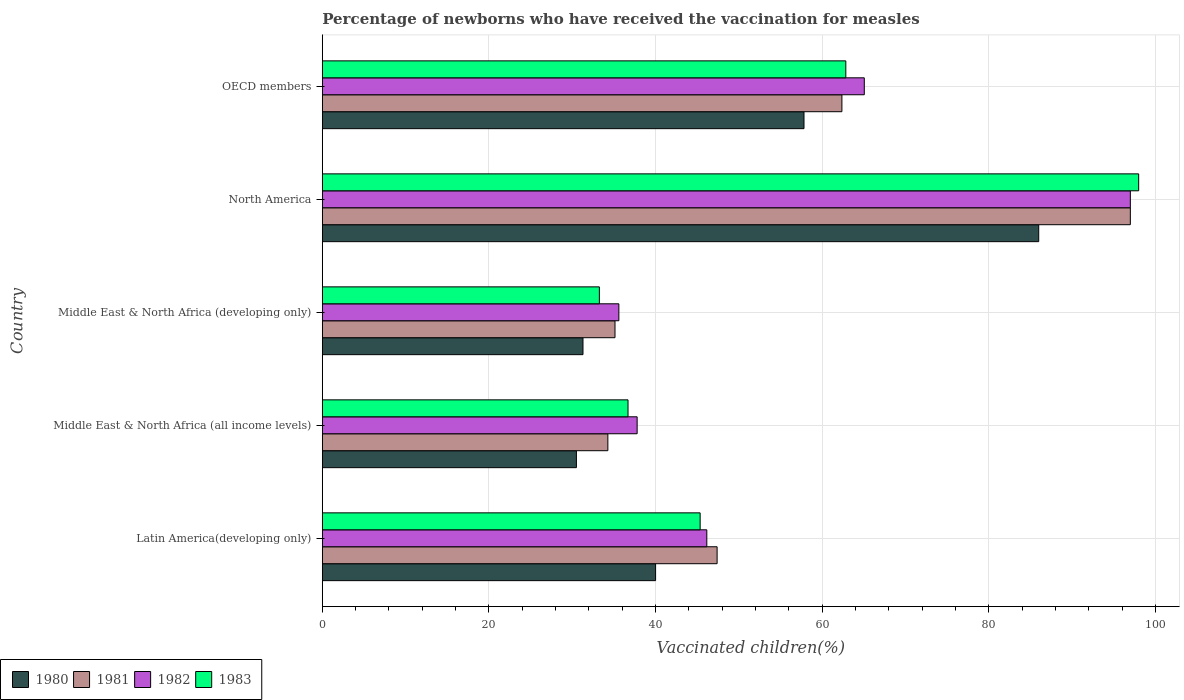How many different coloured bars are there?
Give a very brief answer. 4. How many groups of bars are there?
Offer a terse response. 5. Are the number of bars per tick equal to the number of legend labels?
Give a very brief answer. Yes. Are the number of bars on each tick of the Y-axis equal?
Your answer should be very brief. Yes. How many bars are there on the 5th tick from the bottom?
Give a very brief answer. 4. What is the label of the 4th group of bars from the top?
Offer a very short reply. Middle East & North Africa (all income levels). What is the percentage of vaccinated children in 1981 in Middle East & North Africa (developing only)?
Provide a succinct answer. 35.13. Across all countries, what is the maximum percentage of vaccinated children in 1980?
Keep it short and to the point. 86. Across all countries, what is the minimum percentage of vaccinated children in 1981?
Your answer should be very brief. 34.28. In which country was the percentage of vaccinated children in 1981 maximum?
Offer a very short reply. North America. In which country was the percentage of vaccinated children in 1983 minimum?
Keep it short and to the point. Middle East & North Africa (developing only). What is the total percentage of vaccinated children in 1980 in the graph?
Keep it short and to the point. 245.62. What is the difference between the percentage of vaccinated children in 1980 in North America and that in OECD members?
Give a very brief answer. 28.18. What is the difference between the percentage of vaccinated children in 1982 in North America and the percentage of vaccinated children in 1983 in Middle East & North Africa (developing only)?
Offer a terse response. 63.74. What is the average percentage of vaccinated children in 1983 per country?
Give a very brief answer. 55.23. What is the difference between the percentage of vaccinated children in 1981 and percentage of vaccinated children in 1982 in North America?
Offer a terse response. 0. In how many countries, is the percentage of vaccinated children in 1981 greater than 40 %?
Provide a succinct answer. 3. What is the ratio of the percentage of vaccinated children in 1982 in Latin America(developing only) to that in OECD members?
Provide a succinct answer. 0.71. Is the percentage of vaccinated children in 1983 in Middle East & North Africa (developing only) less than that in North America?
Make the answer very short. Yes. What is the difference between the highest and the second highest percentage of vaccinated children in 1983?
Your answer should be very brief. 35.16. What is the difference between the highest and the lowest percentage of vaccinated children in 1983?
Offer a terse response. 64.74. In how many countries, is the percentage of vaccinated children in 1980 greater than the average percentage of vaccinated children in 1980 taken over all countries?
Offer a very short reply. 2. Is the sum of the percentage of vaccinated children in 1982 in Middle East & North Africa (developing only) and North America greater than the maximum percentage of vaccinated children in 1983 across all countries?
Provide a succinct answer. Yes. Is it the case that in every country, the sum of the percentage of vaccinated children in 1981 and percentage of vaccinated children in 1982 is greater than the sum of percentage of vaccinated children in 1980 and percentage of vaccinated children in 1983?
Your answer should be very brief. No. How many bars are there?
Your answer should be very brief. 20. Are all the bars in the graph horizontal?
Ensure brevity in your answer.  Yes. What is the difference between two consecutive major ticks on the X-axis?
Give a very brief answer. 20. Where does the legend appear in the graph?
Offer a terse response. Bottom left. How are the legend labels stacked?
Ensure brevity in your answer.  Horizontal. What is the title of the graph?
Give a very brief answer. Percentage of newborns who have received the vaccination for measles. What is the label or title of the X-axis?
Your answer should be very brief. Vaccinated children(%). What is the Vaccinated children(%) of 1980 in Latin America(developing only)?
Ensure brevity in your answer.  40.01. What is the Vaccinated children(%) of 1981 in Latin America(developing only)?
Make the answer very short. 47.39. What is the Vaccinated children(%) of 1982 in Latin America(developing only)?
Provide a short and direct response. 46.16. What is the Vaccinated children(%) of 1983 in Latin America(developing only)?
Your response must be concise. 45.35. What is the Vaccinated children(%) of 1980 in Middle East & North Africa (all income levels)?
Make the answer very short. 30.5. What is the Vaccinated children(%) in 1981 in Middle East & North Africa (all income levels)?
Your answer should be compact. 34.28. What is the Vaccinated children(%) of 1982 in Middle East & North Africa (all income levels)?
Offer a very short reply. 37.79. What is the Vaccinated children(%) in 1983 in Middle East & North Africa (all income levels)?
Provide a short and direct response. 36.7. What is the Vaccinated children(%) of 1980 in Middle East & North Africa (developing only)?
Offer a very short reply. 31.29. What is the Vaccinated children(%) in 1981 in Middle East & North Africa (developing only)?
Your answer should be compact. 35.13. What is the Vaccinated children(%) of 1982 in Middle East & North Africa (developing only)?
Offer a terse response. 35.6. What is the Vaccinated children(%) of 1983 in Middle East & North Africa (developing only)?
Provide a short and direct response. 33.26. What is the Vaccinated children(%) in 1980 in North America?
Make the answer very short. 86. What is the Vaccinated children(%) of 1981 in North America?
Provide a short and direct response. 97. What is the Vaccinated children(%) of 1982 in North America?
Keep it short and to the point. 97. What is the Vaccinated children(%) of 1980 in OECD members?
Your answer should be very brief. 57.82. What is the Vaccinated children(%) of 1981 in OECD members?
Offer a very short reply. 62.37. What is the Vaccinated children(%) of 1982 in OECD members?
Provide a short and direct response. 65.06. What is the Vaccinated children(%) in 1983 in OECD members?
Ensure brevity in your answer.  62.84. Across all countries, what is the maximum Vaccinated children(%) in 1980?
Give a very brief answer. 86. Across all countries, what is the maximum Vaccinated children(%) in 1981?
Keep it short and to the point. 97. Across all countries, what is the maximum Vaccinated children(%) of 1982?
Make the answer very short. 97. Across all countries, what is the minimum Vaccinated children(%) of 1980?
Provide a succinct answer. 30.5. Across all countries, what is the minimum Vaccinated children(%) in 1981?
Your answer should be compact. 34.28. Across all countries, what is the minimum Vaccinated children(%) in 1982?
Provide a short and direct response. 35.6. Across all countries, what is the minimum Vaccinated children(%) of 1983?
Make the answer very short. 33.26. What is the total Vaccinated children(%) of 1980 in the graph?
Give a very brief answer. 245.62. What is the total Vaccinated children(%) in 1981 in the graph?
Give a very brief answer. 276.18. What is the total Vaccinated children(%) of 1982 in the graph?
Your response must be concise. 281.61. What is the total Vaccinated children(%) in 1983 in the graph?
Ensure brevity in your answer.  276.15. What is the difference between the Vaccinated children(%) in 1980 in Latin America(developing only) and that in Middle East & North Africa (all income levels)?
Your answer should be compact. 9.51. What is the difference between the Vaccinated children(%) in 1981 in Latin America(developing only) and that in Middle East & North Africa (all income levels)?
Your answer should be compact. 13.11. What is the difference between the Vaccinated children(%) in 1982 in Latin America(developing only) and that in Middle East & North Africa (all income levels)?
Your answer should be compact. 8.36. What is the difference between the Vaccinated children(%) in 1983 in Latin America(developing only) and that in Middle East & North Africa (all income levels)?
Your answer should be compact. 8.66. What is the difference between the Vaccinated children(%) in 1980 in Latin America(developing only) and that in Middle East & North Africa (developing only)?
Provide a succinct answer. 8.72. What is the difference between the Vaccinated children(%) of 1981 in Latin America(developing only) and that in Middle East & North Africa (developing only)?
Keep it short and to the point. 12.26. What is the difference between the Vaccinated children(%) in 1982 in Latin America(developing only) and that in Middle East & North Africa (developing only)?
Make the answer very short. 10.56. What is the difference between the Vaccinated children(%) of 1983 in Latin America(developing only) and that in Middle East & North Africa (developing only)?
Offer a terse response. 12.1. What is the difference between the Vaccinated children(%) in 1980 in Latin America(developing only) and that in North America?
Ensure brevity in your answer.  -45.99. What is the difference between the Vaccinated children(%) in 1981 in Latin America(developing only) and that in North America?
Ensure brevity in your answer.  -49.61. What is the difference between the Vaccinated children(%) in 1982 in Latin America(developing only) and that in North America?
Provide a short and direct response. -50.84. What is the difference between the Vaccinated children(%) in 1983 in Latin America(developing only) and that in North America?
Make the answer very short. -52.65. What is the difference between the Vaccinated children(%) in 1980 in Latin America(developing only) and that in OECD members?
Offer a terse response. -17.82. What is the difference between the Vaccinated children(%) of 1981 in Latin America(developing only) and that in OECD members?
Your answer should be very brief. -14.98. What is the difference between the Vaccinated children(%) of 1982 in Latin America(developing only) and that in OECD members?
Make the answer very short. -18.91. What is the difference between the Vaccinated children(%) in 1983 in Latin America(developing only) and that in OECD members?
Make the answer very short. -17.49. What is the difference between the Vaccinated children(%) in 1980 in Middle East & North Africa (all income levels) and that in Middle East & North Africa (developing only)?
Make the answer very short. -0.79. What is the difference between the Vaccinated children(%) in 1981 in Middle East & North Africa (all income levels) and that in Middle East & North Africa (developing only)?
Offer a very short reply. -0.86. What is the difference between the Vaccinated children(%) in 1982 in Middle East & North Africa (all income levels) and that in Middle East & North Africa (developing only)?
Give a very brief answer. 2.19. What is the difference between the Vaccinated children(%) in 1983 in Middle East & North Africa (all income levels) and that in Middle East & North Africa (developing only)?
Your answer should be very brief. 3.44. What is the difference between the Vaccinated children(%) in 1980 in Middle East & North Africa (all income levels) and that in North America?
Your answer should be compact. -55.5. What is the difference between the Vaccinated children(%) of 1981 in Middle East & North Africa (all income levels) and that in North America?
Your answer should be very brief. -62.72. What is the difference between the Vaccinated children(%) of 1982 in Middle East & North Africa (all income levels) and that in North America?
Give a very brief answer. -59.21. What is the difference between the Vaccinated children(%) in 1983 in Middle East & North Africa (all income levels) and that in North America?
Provide a succinct answer. -61.3. What is the difference between the Vaccinated children(%) of 1980 in Middle East & North Africa (all income levels) and that in OECD members?
Offer a very short reply. -27.32. What is the difference between the Vaccinated children(%) of 1981 in Middle East & North Africa (all income levels) and that in OECD members?
Your answer should be very brief. -28.1. What is the difference between the Vaccinated children(%) in 1982 in Middle East & North Africa (all income levels) and that in OECD members?
Your response must be concise. -27.27. What is the difference between the Vaccinated children(%) of 1983 in Middle East & North Africa (all income levels) and that in OECD members?
Offer a terse response. -26.15. What is the difference between the Vaccinated children(%) of 1980 in Middle East & North Africa (developing only) and that in North America?
Your answer should be compact. -54.71. What is the difference between the Vaccinated children(%) in 1981 in Middle East & North Africa (developing only) and that in North America?
Your answer should be compact. -61.87. What is the difference between the Vaccinated children(%) in 1982 in Middle East & North Africa (developing only) and that in North America?
Offer a terse response. -61.4. What is the difference between the Vaccinated children(%) in 1983 in Middle East & North Africa (developing only) and that in North America?
Make the answer very short. -64.74. What is the difference between the Vaccinated children(%) of 1980 in Middle East & North Africa (developing only) and that in OECD members?
Offer a very short reply. -26.53. What is the difference between the Vaccinated children(%) in 1981 in Middle East & North Africa (developing only) and that in OECD members?
Offer a very short reply. -27.24. What is the difference between the Vaccinated children(%) of 1982 in Middle East & North Africa (developing only) and that in OECD members?
Make the answer very short. -29.46. What is the difference between the Vaccinated children(%) in 1983 in Middle East & North Africa (developing only) and that in OECD members?
Your answer should be very brief. -29.59. What is the difference between the Vaccinated children(%) of 1980 in North America and that in OECD members?
Provide a succinct answer. 28.18. What is the difference between the Vaccinated children(%) in 1981 in North America and that in OECD members?
Ensure brevity in your answer.  34.63. What is the difference between the Vaccinated children(%) in 1982 in North America and that in OECD members?
Make the answer very short. 31.94. What is the difference between the Vaccinated children(%) in 1983 in North America and that in OECD members?
Offer a very short reply. 35.16. What is the difference between the Vaccinated children(%) of 1980 in Latin America(developing only) and the Vaccinated children(%) of 1981 in Middle East & North Africa (all income levels)?
Offer a terse response. 5.73. What is the difference between the Vaccinated children(%) of 1980 in Latin America(developing only) and the Vaccinated children(%) of 1982 in Middle East & North Africa (all income levels)?
Offer a terse response. 2.22. What is the difference between the Vaccinated children(%) of 1980 in Latin America(developing only) and the Vaccinated children(%) of 1983 in Middle East & North Africa (all income levels)?
Give a very brief answer. 3.31. What is the difference between the Vaccinated children(%) in 1981 in Latin America(developing only) and the Vaccinated children(%) in 1982 in Middle East & North Africa (all income levels)?
Provide a succinct answer. 9.6. What is the difference between the Vaccinated children(%) in 1981 in Latin America(developing only) and the Vaccinated children(%) in 1983 in Middle East & North Africa (all income levels)?
Your answer should be compact. 10.7. What is the difference between the Vaccinated children(%) in 1982 in Latin America(developing only) and the Vaccinated children(%) in 1983 in Middle East & North Africa (all income levels)?
Your answer should be compact. 9.46. What is the difference between the Vaccinated children(%) in 1980 in Latin America(developing only) and the Vaccinated children(%) in 1981 in Middle East & North Africa (developing only)?
Provide a short and direct response. 4.87. What is the difference between the Vaccinated children(%) of 1980 in Latin America(developing only) and the Vaccinated children(%) of 1982 in Middle East & North Africa (developing only)?
Your answer should be very brief. 4.41. What is the difference between the Vaccinated children(%) of 1980 in Latin America(developing only) and the Vaccinated children(%) of 1983 in Middle East & North Africa (developing only)?
Make the answer very short. 6.75. What is the difference between the Vaccinated children(%) in 1981 in Latin America(developing only) and the Vaccinated children(%) in 1982 in Middle East & North Africa (developing only)?
Make the answer very short. 11.8. What is the difference between the Vaccinated children(%) in 1981 in Latin America(developing only) and the Vaccinated children(%) in 1983 in Middle East & North Africa (developing only)?
Your answer should be very brief. 14.14. What is the difference between the Vaccinated children(%) in 1982 in Latin America(developing only) and the Vaccinated children(%) in 1983 in Middle East & North Africa (developing only)?
Ensure brevity in your answer.  12.9. What is the difference between the Vaccinated children(%) in 1980 in Latin America(developing only) and the Vaccinated children(%) in 1981 in North America?
Your answer should be very brief. -56.99. What is the difference between the Vaccinated children(%) in 1980 in Latin America(developing only) and the Vaccinated children(%) in 1982 in North America?
Your answer should be very brief. -56.99. What is the difference between the Vaccinated children(%) in 1980 in Latin America(developing only) and the Vaccinated children(%) in 1983 in North America?
Keep it short and to the point. -57.99. What is the difference between the Vaccinated children(%) in 1981 in Latin America(developing only) and the Vaccinated children(%) in 1982 in North America?
Ensure brevity in your answer.  -49.61. What is the difference between the Vaccinated children(%) in 1981 in Latin America(developing only) and the Vaccinated children(%) in 1983 in North America?
Ensure brevity in your answer.  -50.61. What is the difference between the Vaccinated children(%) in 1982 in Latin America(developing only) and the Vaccinated children(%) in 1983 in North America?
Keep it short and to the point. -51.84. What is the difference between the Vaccinated children(%) of 1980 in Latin America(developing only) and the Vaccinated children(%) of 1981 in OECD members?
Your response must be concise. -22.37. What is the difference between the Vaccinated children(%) in 1980 in Latin America(developing only) and the Vaccinated children(%) in 1982 in OECD members?
Provide a short and direct response. -25.05. What is the difference between the Vaccinated children(%) of 1980 in Latin America(developing only) and the Vaccinated children(%) of 1983 in OECD members?
Make the answer very short. -22.84. What is the difference between the Vaccinated children(%) of 1981 in Latin America(developing only) and the Vaccinated children(%) of 1982 in OECD members?
Your answer should be compact. -17.67. What is the difference between the Vaccinated children(%) of 1981 in Latin America(developing only) and the Vaccinated children(%) of 1983 in OECD members?
Give a very brief answer. -15.45. What is the difference between the Vaccinated children(%) in 1982 in Latin America(developing only) and the Vaccinated children(%) in 1983 in OECD members?
Give a very brief answer. -16.69. What is the difference between the Vaccinated children(%) in 1980 in Middle East & North Africa (all income levels) and the Vaccinated children(%) in 1981 in Middle East & North Africa (developing only)?
Provide a short and direct response. -4.63. What is the difference between the Vaccinated children(%) in 1980 in Middle East & North Africa (all income levels) and the Vaccinated children(%) in 1982 in Middle East & North Africa (developing only)?
Provide a succinct answer. -5.1. What is the difference between the Vaccinated children(%) in 1980 in Middle East & North Africa (all income levels) and the Vaccinated children(%) in 1983 in Middle East & North Africa (developing only)?
Your answer should be very brief. -2.75. What is the difference between the Vaccinated children(%) in 1981 in Middle East & North Africa (all income levels) and the Vaccinated children(%) in 1982 in Middle East & North Africa (developing only)?
Your answer should be very brief. -1.32. What is the difference between the Vaccinated children(%) of 1981 in Middle East & North Africa (all income levels) and the Vaccinated children(%) of 1983 in Middle East & North Africa (developing only)?
Offer a very short reply. 1.02. What is the difference between the Vaccinated children(%) in 1982 in Middle East & North Africa (all income levels) and the Vaccinated children(%) in 1983 in Middle East & North Africa (developing only)?
Provide a succinct answer. 4.54. What is the difference between the Vaccinated children(%) of 1980 in Middle East & North Africa (all income levels) and the Vaccinated children(%) of 1981 in North America?
Ensure brevity in your answer.  -66.5. What is the difference between the Vaccinated children(%) in 1980 in Middle East & North Africa (all income levels) and the Vaccinated children(%) in 1982 in North America?
Your response must be concise. -66.5. What is the difference between the Vaccinated children(%) of 1980 in Middle East & North Africa (all income levels) and the Vaccinated children(%) of 1983 in North America?
Provide a short and direct response. -67.5. What is the difference between the Vaccinated children(%) in 1981 in Middle East & North Africa (all income levels) and the Vaccinated children(%) in 1982 in North America?
Your answer should be compact. -62.72. What is the difference between the Vaccinated children(%) in 1981 in Middle East & North Africa (all income levels) and the Vaccinated children(%) in 1983 in North America?
Your response must be concise. -63.72. What is the difference between the Vaccinated children(%) in 1982 in Middle East & North Africa (all income levels) and the Vaccinated children(%) in 1983 in North America?
Provide a short and direct response. -60.21. What is the difference between the Vaccinated children(%) of 1980 in Middle East & North Africa (all income levels) and the Vaccinated children(%) of 1981 in OECD members?
Offer a very short reply. -31.87. What is the difference between the Vaccinated children(%) of 1980 in Middle East & North Africa (all income levels) and the Vaccinated children(%) of 1982 in OECD members?
Provide a short and direct response. -34.56. What is the difference between the Vaccinated children(%) in 1980 in Middle East & North Africa (all income levels) and the Vaccinated children(%) in 1983 in OECD members?
Your answer should be very brief. -32.34. What is the difference between the Vaccinated children(%) of 1981 in Middle East & North Africa (all income levels) and the Vaccinated children(%) of 1982 in OECD members?
Your answer should be compact. -30.78. What is the difference between the Vaccinated children(%) of 1981 in Middle East & North Africa (all income levels) and the Vaccinated children(%) of 1983 in OECD members?
Provide a succinct answer. -28.57. What is the difference between the Vaccinated children(%) of 1982 in Middle East & North Africa (all income levels) and the Vaccinated children(%) of 1983 in OECD members?
Provide a short and direct response. -25.05. What is the difference between the Vaccinated children(%) in 1980 in Middle East & North Africa (developing only) and the Vaccinated children(%) in 1981 in North America?
Keep it short and to the point. -65.71. What is the difference between the Vaccinated children(%) in 1980 in Middle East & North Africa (developing only) and the Vaccinated children(%) in 1982 in North America?
Give a very brief answer. -65.71. What is the difference between the Vaccinated children(%) in 1980 in Middle East & North Africa (developing only) and the Vaccinated children(%) in 1983 in North America?
Your response must be concise. -66.71. What is the difference between the Vaccinated children(%) in 1981 in Middle East & North Africa (developing only) and the Vaccinated children(%) in 1982 in North America?
Ensure brevity in your answer.  -61.87. What is the difference between the Vaccinated children(%) of 1981 in Middle East & North Africa (developing only) and the Vaccinated children(%) of 1983 in North America?
Your answer should be compact. -62.87. What is the difference between the Vaccinated children(%) of 1982 in Middle East & North Africa (developing only) and the Vaccinated children(%) of 1983 in North America?
Your answer should be very brief. -62.4. What is the difference between the Vaccinated children(%) in 1980 in Middle East & North Africa (developing only) and the Vaccinated children(%) in 1981 in OECD members?
Offer a terse response. -31.08. What is the difference between the Vaccinated children(%) of 1980 in Middle East & North Africa (developing only) and the Vaccinated children(%) of 1982 in OECD members?
Your answer should be compact. -33.77. What is the difference between the Vaccinated children(%) of 1980 in Middle East & North Africa (developing only) and the Vaccinated children(%) of 1983 in OECD members?
Provide a short and direct response. -31.55. What is the difference between the Vaccinated children(%) in 1981 in Middle East & North Africa (developing only) and the Vaccinated children(%) in 1982 in OECD members?
Offer a terse response. -29.93. What is the difference between the Vaccinated children(%) in 1981 in Middle East & North Africa (developing only) and the Vaccinated children(%) in 1983 in OECD members?
Your response must be concise. -27.71. What is the difference between the Vaccinated children(%) in 1982 in Middle East & North Africa (developing only) and the Vaccinated children(%) in 1983 in OECD members?
Offer a terse response. -27.25. What is the difference between the Vaccinated children(%) of 1980 in North America and the Vaccinated children(%) of 1981 in OECD members?
Offer a very short reply. 23.63. What is the difference between the Vaccinated children(%) of 1980 in North America and the Vaccinated children(%) of 1982 in OECD members?
Offer a very short reply. 20.94. What is the difference between the Vaccinated children(%) of 1980 in North America and the Vaccinated children(%) of 1983 in OECD members?
Make the answer very short. 23.16. What is the difference between the Vaccinated children(%) of 1981 in North America and the Vaccinated children(%) of 1982 in OECD members?
Provide a short and direct response. 31.94. What is the difference between the Vaccinated children(%) in 1981 in North America and the Vaccinated children(%) in 1983 in OECD members?
Keep it short and to the point. 34.16. What is the difference between the Vaccinated children(%) of 1982 in North America and the Vaccinated children(%) of 1983 in OECD members?
Your response must be concise. 34.16. What is the average Vaccinated children(%) in 1980 per country?
Offer a terse response. 49.12. What is the average Vaccinated children(%) of 1981 per country?
Offer a terse response. 55.24. What is the average Vaccinated children(%) of 1982 per country?
Make the answer very short. 56.32. What is the average Vaccinated children(%) of 1983 per country?
Make the answer very short. 55.23. What is the difference between the Vaccinated children(%) of 1980 and Vaccinated children(%) of 1981 in Latin America(developing only)?
Keep it short and to the point. -7.39. What is the difference between the Vaccinated children(%) of 1980 and Vaccinated children(%) of 1982 in Latin America(developing only)?
Make the answer very short. -6.15. What is the difference between the Vaccinated children(%) of 1980 and Vaccinated children(%) of 1983 in Latin America(developing only)?
Make the answer very short. -5.35. What is the difference between the Vaccinated children(%) of 1981 and Vaccinated children(%) of 1982 in Latin America(developing only)?
Make the answer very short. 1.24. What is the difference between the Vaccinated children(%) of 1981 and Vaccinated children(%) of 1983 in Latin America(developing only)?
Ensure brevity in your answer.  2.04. What is the difference between the Vaccinated children(%) in 1982 and Vaccinated children(%) in 1983 in Latin America(developing only)?
Make the answer very short. 0.8. What is the difference between the Vaccinated children(%) in 1980 and Vaccinated children(%) in 1981 in Middle East & North Africa (all income levels)?
Ensure brevity in your answer.  -3.78. What is the difference between the Vaccinated children(%) in 1980 and Vaccinated children(%) in 1982 in Middle East & North Africa (all income levels)?
Your answer should be very brief. -7.29. What is the difference between the Vaccinated children(%) in 1980 and Vaccinated children(%) in 1983 in Middle East & North Africa (all income levels)?
Give a very brief answer. -6.19. What is the difference between the Vaccinated children(%) of 1981 and Vaccinated children(%) of 1982 in Middle East & North Africa (all income levels)?
Make the answer very short. -3.51. What is the difference between the Vaccinated children(%) of 1981 and Vaccinated children(%) of 1983 in Middle East & North Africa (all income levels)?
Your response must be concise. -2.42. What is the difference between the Vaccinated children(%) of 1982 and Vaccinated children(%) of 1983 in Middle East & North Africa (all income levels)?
Your answer should be compact. 1.1. What is the difference between the Vaccinated children(%) in 1980 and Vaccinated children(%) in 1981 in Middle East & North Africa (developing only)?
Give a very brief answer. -3.84. What is the difference between the Vaccinated children(%) of 1980 and Vaccinated children(%) of 1982 in Middle East & North Africa (developing only)?
Provide a succinct answer. -4.31. What is the difference between the Vaccinated children(%) in 1980 and Vaccinated children(%) in 1983 in Middle East & North Africa (developing only)?
Make the answer very short. -1.97. What is the difference between the Vaccinated children(%) in 1981 and Vaccinated children(%) in 1982 in Middle East & North Africa (developing only)?
Provide a succinct answer. -0.46. What is the difference between the Vaccinated children(%) of 1981 and Vaccinated children(%) of 1983 in Middle East & North Africa (developing only)?
Your answer should be very brief. 1.88. What is the difference between the Vaccinated children(%) in 1982 and Vaccinated children(%) in 1983 in Middle East & North Africa (developing only)?
Give a very brief answer. 2.34. What is the difference between the Vaccinated children(%) of 1980 and Vaccinated children(%) of 1981 in North America?
Ensure brevity in your answer.  -11. What is the difference between the Vaccinated children(%) in 1980 and Vaccinated children(%) in 1982 in North America?
Your answer should be very brief. -11. What is the difference between the Vaccinated children(%) in 1981 and Vaccinated children(%) in 1982 in North America?
Offer a terse response. 0. What is the difference between the Vaccinated children(%) of 1981 and Vaccinated children(%) of 1983 in North America?
Provide a succinct answer. -1. What is the difference between the Vaccinated children(%) of 1982 and Vaccinated children(%) of 1983 in North America?
Provide a short and direct response. -1. What is the difference between the Vaccinated children(%) in 1980 and Vaccinated children(%) in 1981 in OECD members?
Your answer should be compact. -4.55. What is the difference between the Vaccinated children(%) of 1980 and Vaccinated children(%) of 1982 in OECD members?
Make the answer very short. -7.24. What is the difference between the Vaccinated children(%) in 1980 and Vaccinated children(%) in 1983 in OECD members?
Give a very brief answer. -5.02. What is the difference between the Vaccinated children(%) of 1981 and Vaccinated children(%) of 1982 in OECD members?
Keep it short and to the point. -2.69. What is the difference between the Vaccinated children(%) in 1981 and Vaccinated children(%) in 1983 in OECD members?
Give a very brief answer. -0.47. What is the difference between the Vaccinated children(%) in 1982 and Vaccinated children(%) in 1983 in OECD members?
Make the answer very short. 2.22. What is the ratio of the Vaccinated children(%) in 1980 in Latin America(developing only) to that in Middle East & North Africa (all income levels)?
Your answer should be compact. 1.31. What is the ratio of the Vaccinated children(%) of 1981 in Latin America(developing only) to that in Middle East & North Africa (all income levels)?
Offer a terse response. 1.38. What is the ratio of the Vaccinated children(%) of 1982 in Latin America(developing only) to that in Middle East & North Africa (all income levels)?
Your answer should be compact. 1.22. What is the ratio of the Vaccinated children(%) of 1983 in Latin America(developing only) to that in Middle East & North Africa (all income levels)?
Ensure brevity in your answer.  1.24. What is the ratio of the Vaccinated children(%) in 1980 in Latin America(developing only) to that in Middle East & North Africa (developing only)?
Provide a short and direct response. 1.28. What is the ratio of the Vaccinated children(%) in 1981 in Latin America(developing only) to that in Middle East & North Africa (developing only)?
Your answer should be compact. 1.35. What is the ratio of the Vaccinated children(%) in 1982 in Latin America(developing only) to that in Middle East & North Africa (developing only)?
Provide a short and direct response. 1.3. What is the ratio of the Vaccinated children(%) in 1983 in Latin America(developing only) to that in Middle East & North Africa (developing only)?
Provide a short and direct response. 1.36. What is the ratio of the Vaccinated children(%) of 1980 in Latin America(developing only) to that in North America?
Offer a terse response. 0.47. What is the ratio of the Vaccinated children(%) of 1981 in Latin America(developing only) to that in North America?
Your answer should be compact. 0.49. What is the ratio of the Vaccinated children(%) in 1982 in Latin America(developing only) to that in North America?
Give a very brief answer. 0.48. What is the ratio of the Vaccinated children(%) of 1983 in Latin America(developing only) to that in North America?
Provide a short and direct response. 0.46. What is the ratio of the Vaccinated children(%) of 1980 in Latin America(developing only) to that in OECD members?
Ensure brevity in your answer.  0.69. What is the ratio of the Vaccinated children(%) of 1981 in Latin America(developing only) to that in OECD members?
Make the answer very short. 0.76. What is the ratio of the Vaccinated children(%) of 1982 in Latin America(developing only) to that in OECD members?
Your response must be concise. 0.71. What is the ratio of the Vaccinated children(%) in 1983 in Latin America(developing only) to that in OECD members?
Your response must be concise. 0.72. What is the ratio of the Vaccinated children(%) of 1980 in Middle East & North Africa (all income levels) to that in Middle East & North Africa (developing only)?
Make the answer very short. 0.97. What is the ratio of the Vaccinated children(%) of 1981 in Middle East & North Africa (all income levels) to that in Middle East & North Africa (developing only)?
Provide a short and direct response. 0.98. What is the ratio of the Vaccinated children(%) in 1982 in Middle East & North Africa (all income levels) to that in Middle East & North Africa (developing only)?
Make the answer very short. 1.06. What is the ratio of the Vaccinated children(%) in 1983 in Middle East & North Africa (all income levels) to that in Middle East & North Africa (developing only)?
Ensure brevity in your answer.  1.1. What is the ratio of the Vaccinated children(%) in 1980 in Middle East & North Africa (all income levels) to that in North America?
Provide a succinct answer. 0.35. What is the ratio of the Vaccinated children(%) of 1981 in Middle East & North Africa (all income levels) to that in North America?
Your answer should be very brief. 0.35. What is the ratio of the Vaccinated children(%) in 1982 in Middle East & North Africa (all income levels) to that in North America?
Make the answer very short. 0.39. What is the ratio of the Vaccinated children(%) in 1983 in Middle East & North Africa (all income levels) to that in North America?
Give a very brief answer. 0.37. What is the ratio of the Vaccinated children(%) in 1980 in Middle East & North Africa (all income levels) to that in OECD members?
Give a very brief answer. 0.53. What is the ratio of the Vaccinated children(%) in 1981 in Middle East & North Africa (all income levels) to that in OECD members?
Offer a very short reply. 0.55. What is the ratio of the Vaccinated children(%) of 1982 in Middle East & North Africa (all income levels) to that in OECD members?
Your answer should be compact. 0.58. What is the ratio of the Vaccinated children(%) of 1983 in Middle East & North Africa (all income levels) to that in OECD members?
Ensure brevity in your answer.  0.58. What is the ratio of the Vaccinated children(%) of 1980 in Middle East & North Africa (developing only) to that in North America?
Offer a very short reply. 0.36. What is the ratio of the Vaccinated children(%) in 1981 in Middle East & North Africa (developing only) to that in North America?
Keep it short and to the point. 0.36. What is the ratio of the Vaccinated children(%) in 1982 in Middle East & North Africa (developing only) to that in North America?
Make the answer very short. 0.37. What is the ratio of the Vaccinated children(%) of 1983 in Middle East & North Africa (developing only) to that in North America?
Give a very brief answer. 0.34. What is the ratio of the Vaccinated children(%) of 1980 in Middle East & North Africa (developing only) to that in OECD members?
Make the answer very short. 0.54. What is the ratio of the Vaccinated children(%) of 1981 in Middle East & North Africa (developing only) to that in OECD members?
Offer a terse response. 0.56. What is the ratio of the Vaccinated children(%) in 1982 in Middle East & North Africa (developing only) to that in OECD members?
Give a very brief answer. 0.55. What is the ratio of the Vaccinated children(%) of 1983 in Middle East & North Africa (developing only) to that in OECD members?
Offer a very short reply. 0.53. What is the ratio of the Vaccinated children(%) in 1980 in North America to that in OECD members?
Offer a very short reply. 1.49. What is the ratio of the Vaccinated children(%) in 1981 in North America to that in OECD members?
Give a very brief answer. 1.56. What is the ratio of the Vaccinated children(%) in 1982 in North America to that in OECD members?
Your answer should be very brief. 1.49. What is the ratio of the Vaccinated children(%) of 1983 in North America to that in OECD members?
Ensure brevity in your answer.  1.56. What is the difference between the highest and the second highest Vaccinated children(%) in 1980?
Your response must be concise. 28.18. What is the difference between the highest and the second highest Vaccinated children(%) of 1981?
Offer a very short reply. 34.63. What is the difference between the highest and the second highest Vaccinated children(%) of 1982?
Your response must be concise. 31.94. What is the difference between the highest and the second highest Vaccinated children(%) of 1983?
Your answer should be very brief. 35.16. What is the difference between the highest and the lowest Vaccinated children(%) of 1980?
Offer a terse response. 55.5. What is the difference between the highest and the lowest Vaccinated children(%) of 1981?
Your response must be concise. 62.72. What is the difference between the highest and the lowest Vaccinated children(%) in 1982?
Your answer should be compact. 61.4. What is the difference between the highest and the lowest Vaccinated children(%) of 1983?
Your answer should be compact. 64.74. 